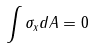Convert formula to latex. <formula><loc_0><loc_0><loc_500><loc_500>\int \sigma _ { x } d A = 0</formula> 